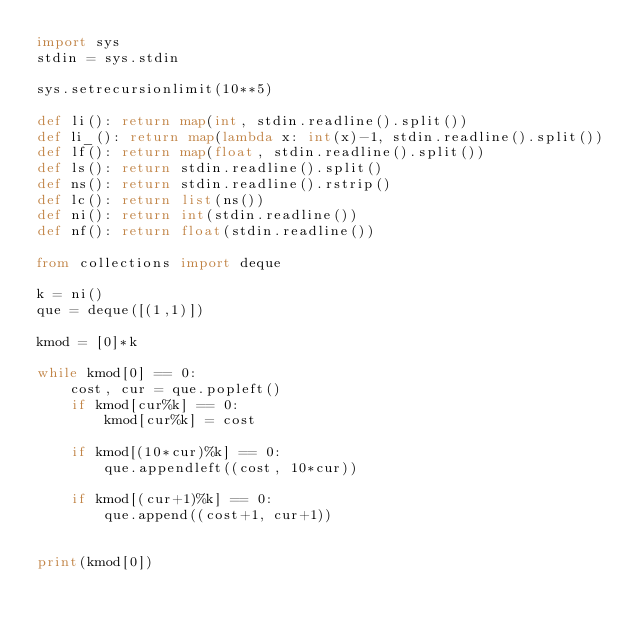<code> <loc_0><loc_0><loc_500><loc_500><_Python_>import sys
stdin = sys.stdin
 
sys.setrecursionlimit(10**5) 
 
def li(): return map(int, stdin.readline().split())
def li_(): return map(lambda x: int(x)-1, stdin.readline().split())
def lf(): return map(float, stdin.readline().split())
def ls(): return stdin.readline().split()
def ns(): return stdin.readline().rstrip()
def lc(): return list(ns())
def ni(): return int(stdin.readline())
def nf(): return float(stdin.readline())

from collections import deque

k = ni()
que = deque([(1,1)])

kmod = [0]*k

while kmod[0] == 0:
    cost, cur = que.popleft()
    if kmod[cur%k] == 0:
        kmod[cur%k] = cost
    
    if kmod[(10*cur)%k] == 0:
        que.appendleft((cost, 10*cur))
    
    if kmod[(cur+1)%k] == 0:
        que.append((cost+1, cur+1))
            
        
print(kmod[0])</code> 